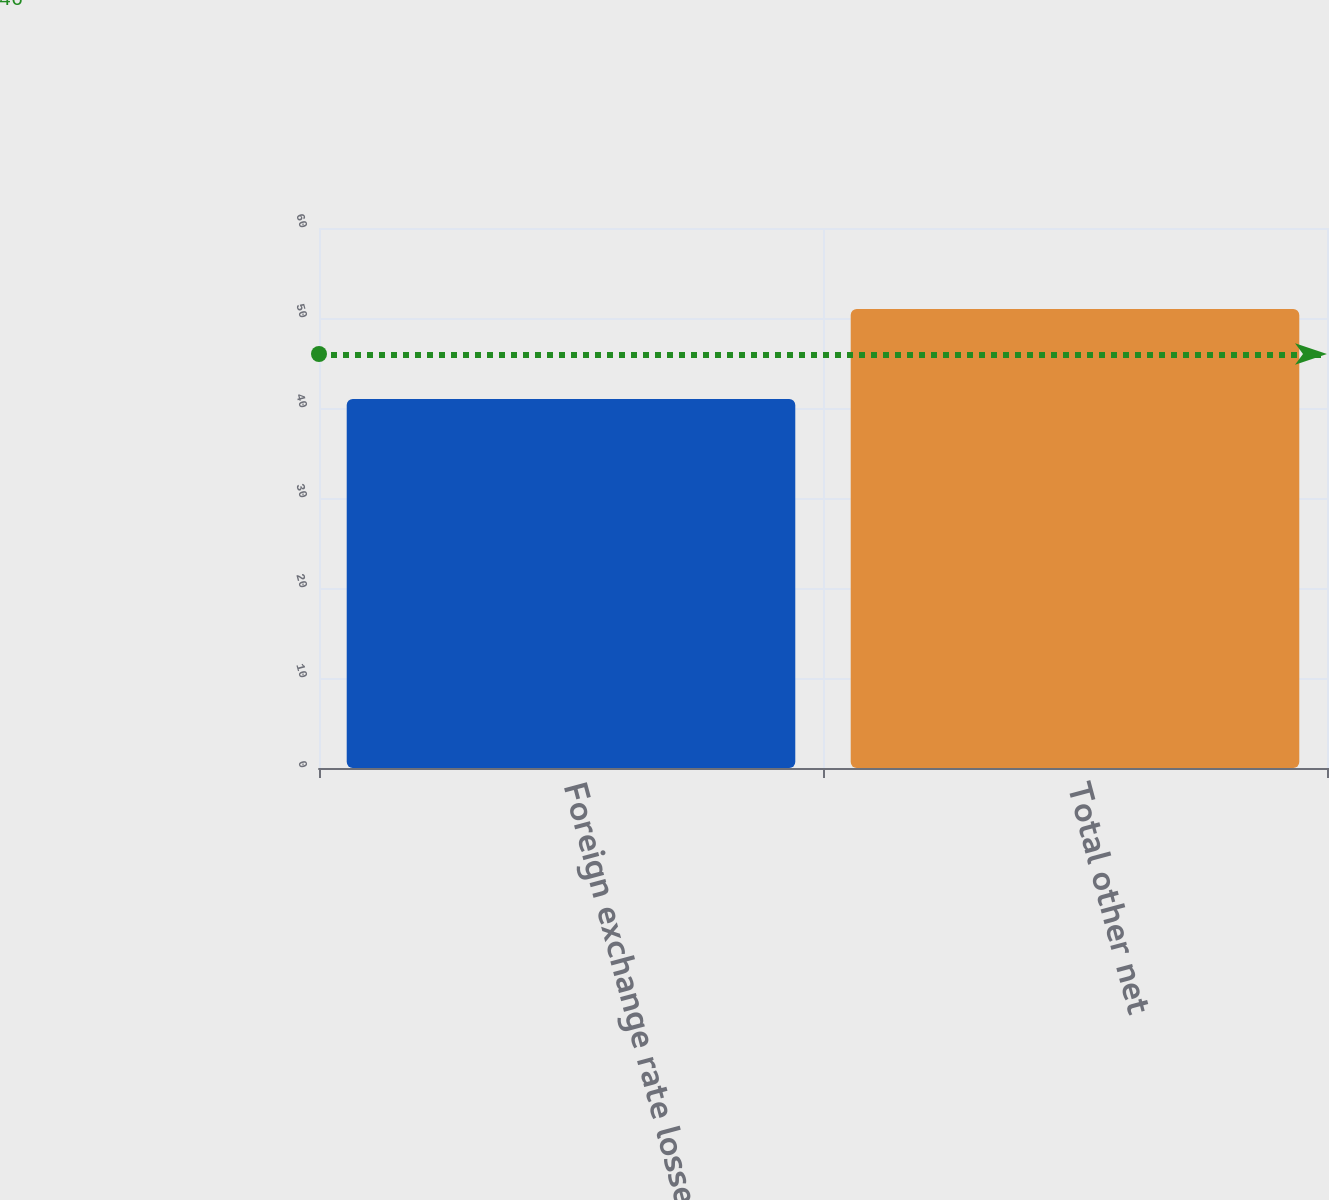Convert chart to OTSL. <chart><loc_0><loc_0><loc_500><loc_500><bar_chart><fcel>Foreign exchange rate losses<fcel>Total other net<nl><fcel>41<fcel>51<nl></chart> 